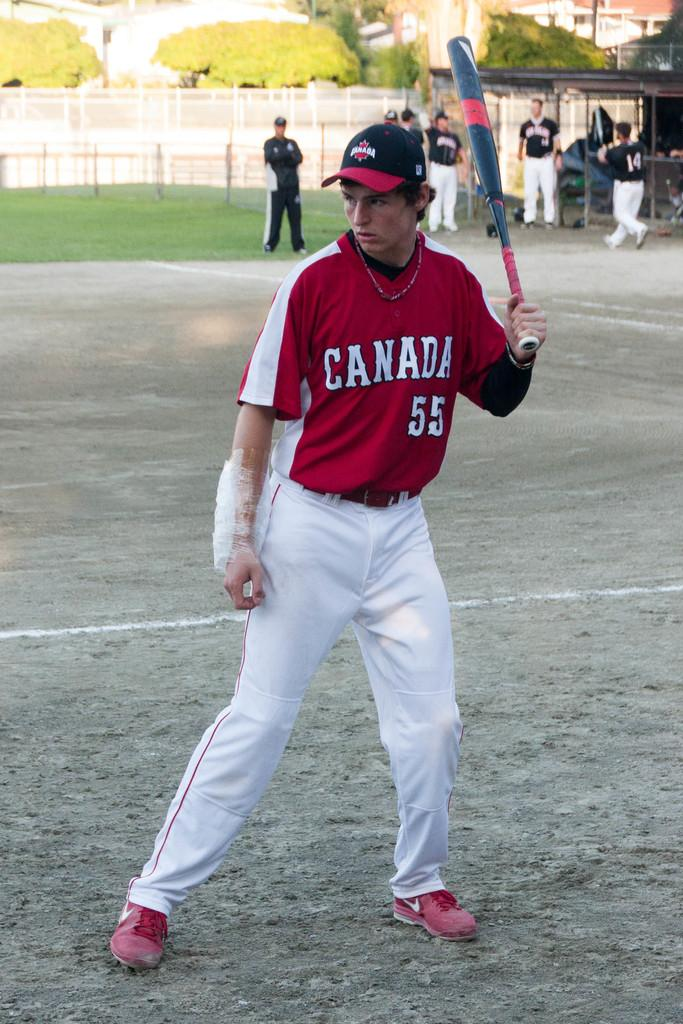<image>
Render a clear and concise summary of the photo. a baseball player for team Canada holding a bat 